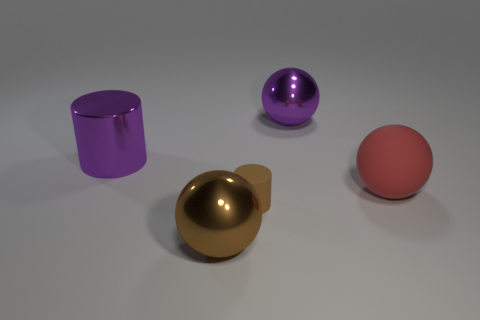Subtract all large metal balls. How many balls are left? 1 Add 4 blue rubber cylinders. How many objects exist? 9 Subtract all cylinders. How many objects are left? 3 Subtract all large green things. Subtract all large purple spheres. How many objects are left? 4 Add 1 large red matte spheres. How many large red matte spheres are left? 2 Add 3 purple metallic cylinders. How many purple metallic cylinders exist? 4 Subtract 1 brown cylinders. How many objects are left? 4 